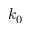<formula> <loc_0><loc_0><loc_500><loc_500>k _ { 0 }</formula> 